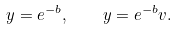Convert formula to latex. <formula><loc_0><loc_0><loc_500><loc_500>y = e ^ { - b } , \quad y = e ^ { - b } v .</formula> 